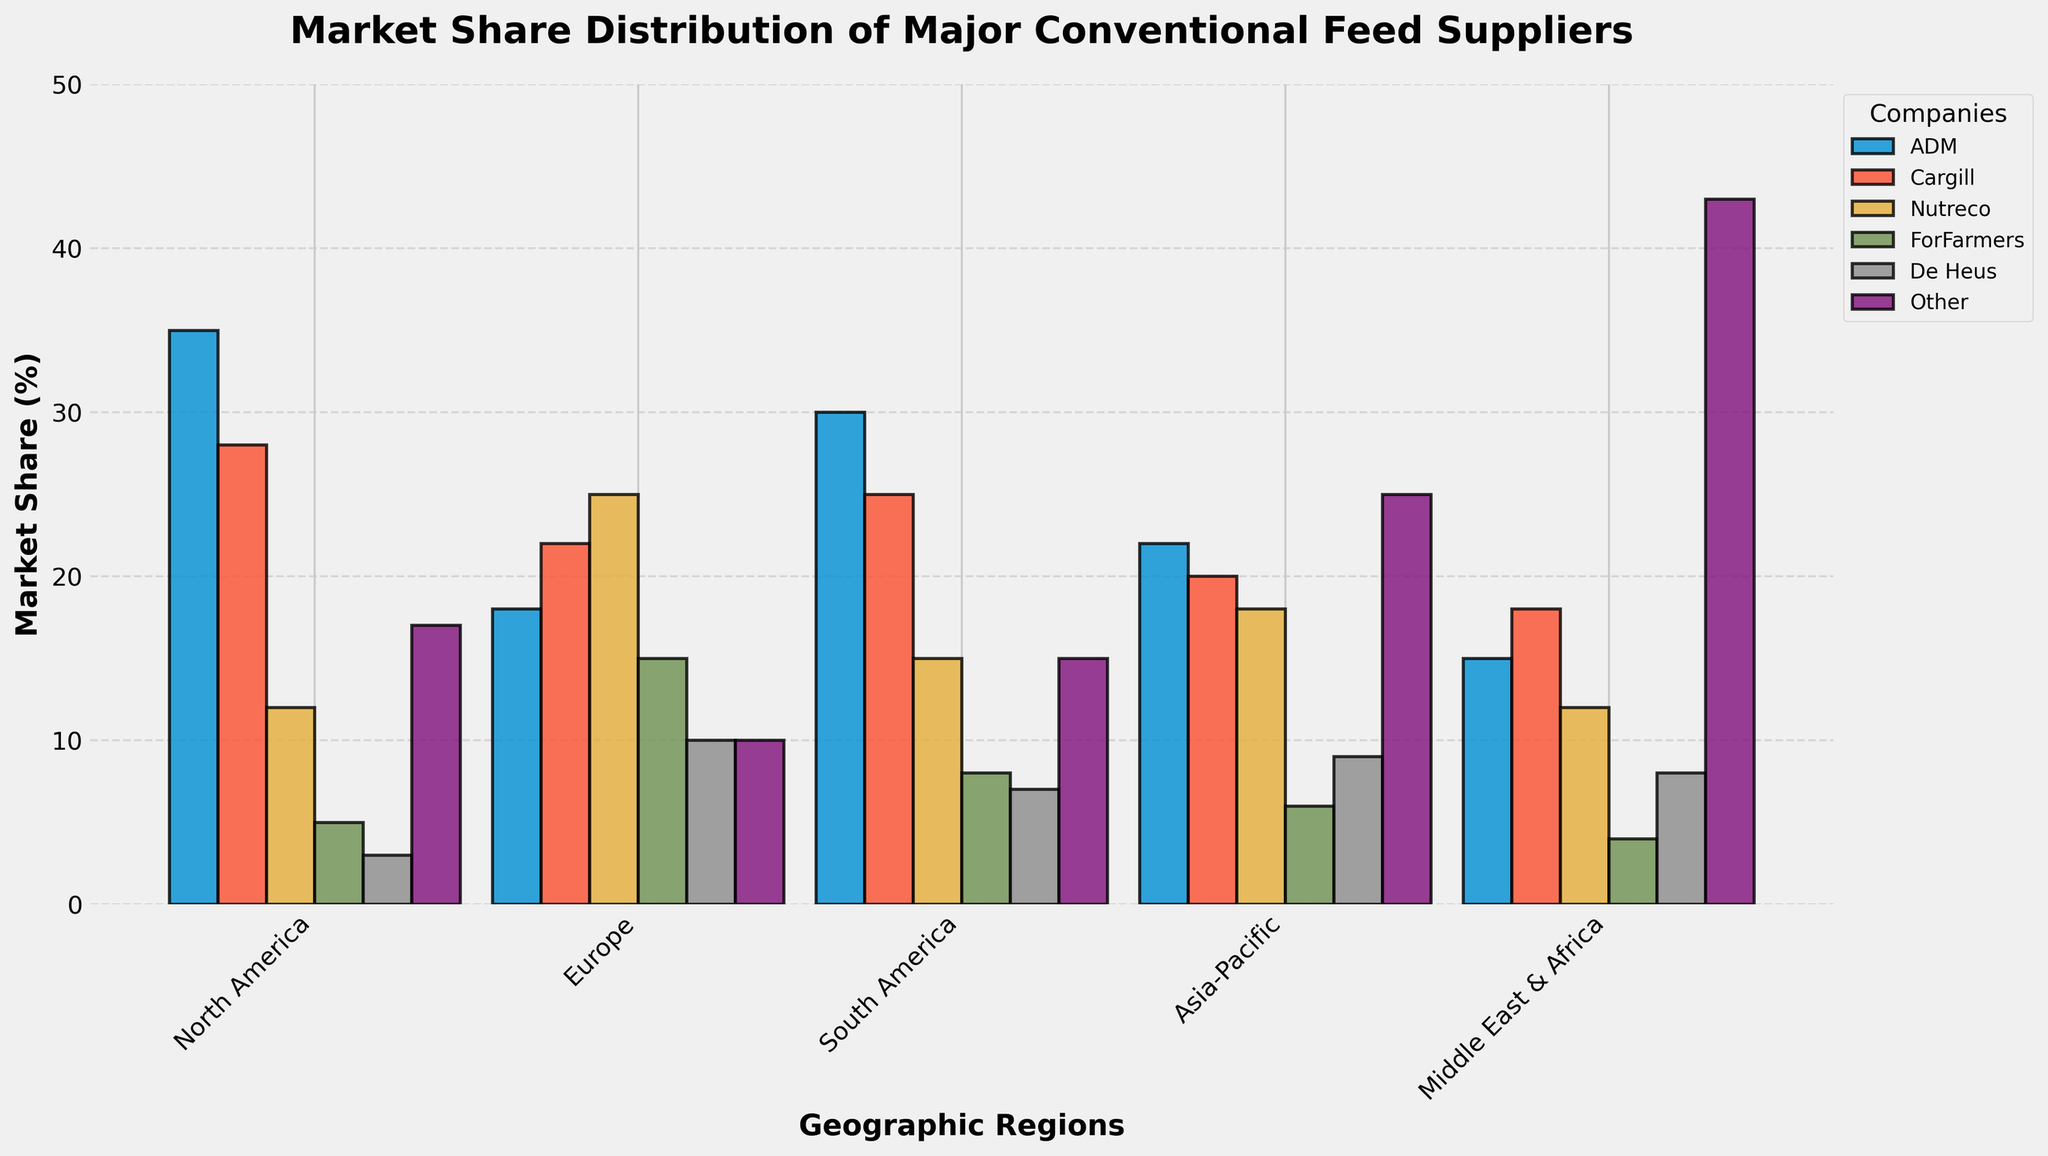Which company has the highest market share in North America? By observing the heights of the bars for North America, ADM has the tallest bar at 35%, which indicates it has the highest market share in North America.
Answer: ADM What is the difference in market share between ADM and Nutreco in South America? The market share of ADM in South America is 30%, and for Nutreco, it is 15%. The difference is calculated as 30% - 15% = 15%.
Answer: 15% In which region does the category "Other" hold the largest market share? By comparing the heights of the "Other" bars across all regions, the "Other" category has the tallest bar in the Middle East & Africa at 43%.
Answer: Middle East & Africa Which two companies have the closest market share in Europe? By observing the heights of the bars in Europe, ADM has 18% and Cargill has 22%, a difference of 4%. Nutreco and De Heus have 25% and 10% respectively, a difference of 15%. Nutreco (25%) and Cargill (22%) have the closest market share with a difference of 3%.
Answer: Nutreco and Cargill What is the average market share of Cargill across all regions? The market share of Cargill in each region is listed as 28%, 22%, 25%, 20%, and 18%. Sum them up: 28 + 22 + 25 + 20 + 18 = 113. There are 5 regions, so the average is 113 / 5 = 22.6%.
Answer: 22.6% In Asia-Pacific, is the market share of ForFarmers closer to the market share of De Heus or "Other"? In Asia-Pacific, ForFarmers has 6%, De Heus has 9%, and "Other" has 25%. The difference between ForFarmers and De Heus is 9% - 6% = 3%, and between ForFarmers and "Other" is 25% - 6% = 19%. Thus, ForFarmers is closer to De Heus.
Answer: De Heus Which company has the same market share in two different regions? Comparing the heights of bars, Nutreco has a market share of 12% in both North America and Middle East & Africa.
Answer: Nutreco What is the total market share of companies excluding the "Other" category in Europe? The market shares of ADM, Cargill, Nutreco, ForFarmers, and De Heus in Europe are 18%, 22%, 25%, 15%, and 10% respectively. Summing these: 18 + 22 + 25 + 15 + 10 = 90%.
Answer: 90% 